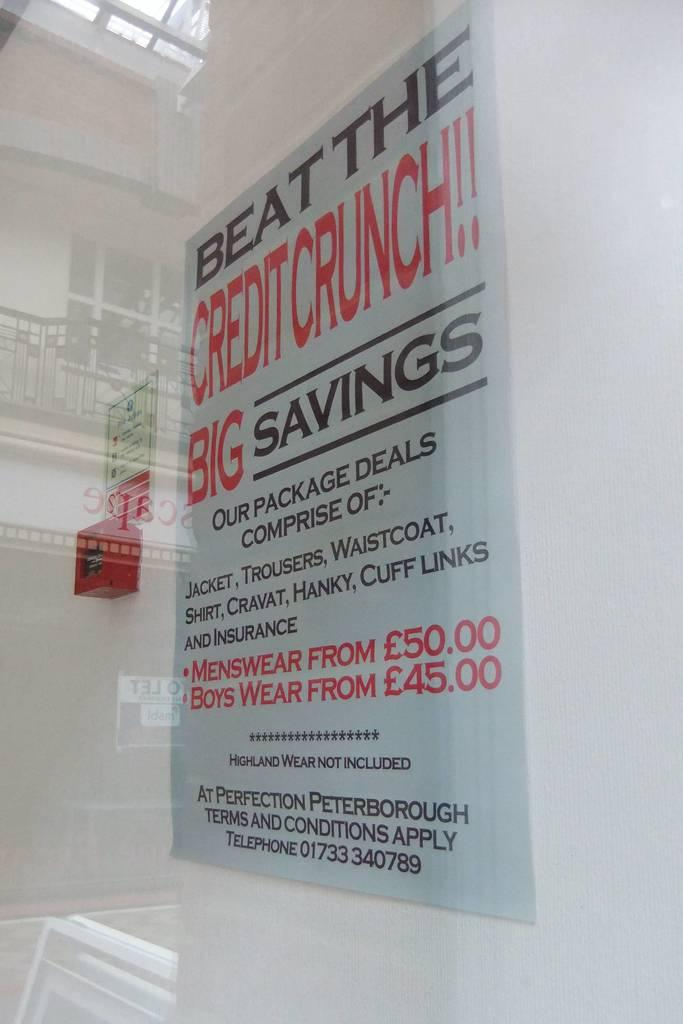<image>
Describe the image concisely. A poster advert to beat the credit crunch for mens clothing. 